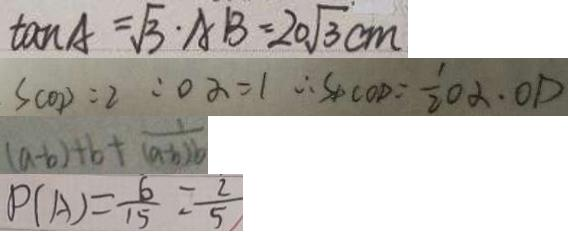<formula> <loc_0><loc_0><loc_500><loc_500>\tan A = \sqrt { 3 } \cdot A B = 2 0 \sqrt { 3 } c m 
 S _ { C O D } = 2 : o \alpha = 1 \therefore S _ { \Delta C O D } = \frac { 1 } { 2 } O \alpha \cdot O D 
 ( a - b ) + b + \frac { 1 } { ( a - b ) b } 
 P ( A ) = \frac { 6 } { 1 5 } = \frac { 2 } { 5 }</formula> 